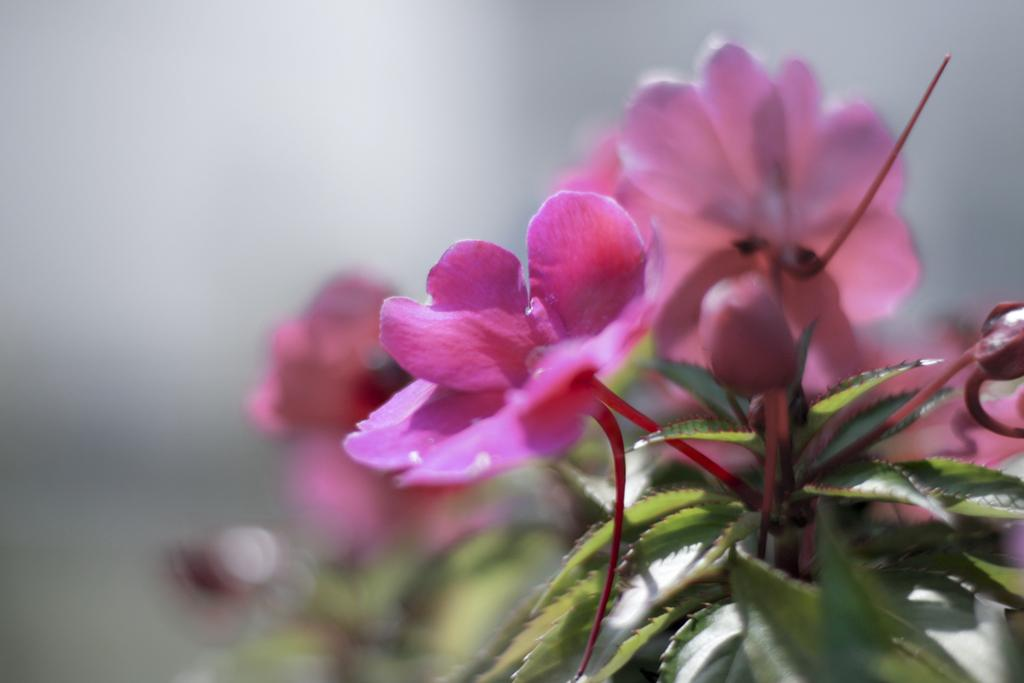What type of plants can be seen in the image? There are flowers in the image. What color are the flowers? The flowers are pink in color. Are there any other parts of the plants visible in the image? Yes, there are leaves associated with the flowers. How would you describe the background of the image? The background of the image is blurred. What type of liquid is being used to clean the toothbrush in the image? There is no toothbrush or liquid present in the image; it features flowers with leaves and a blurred background. 